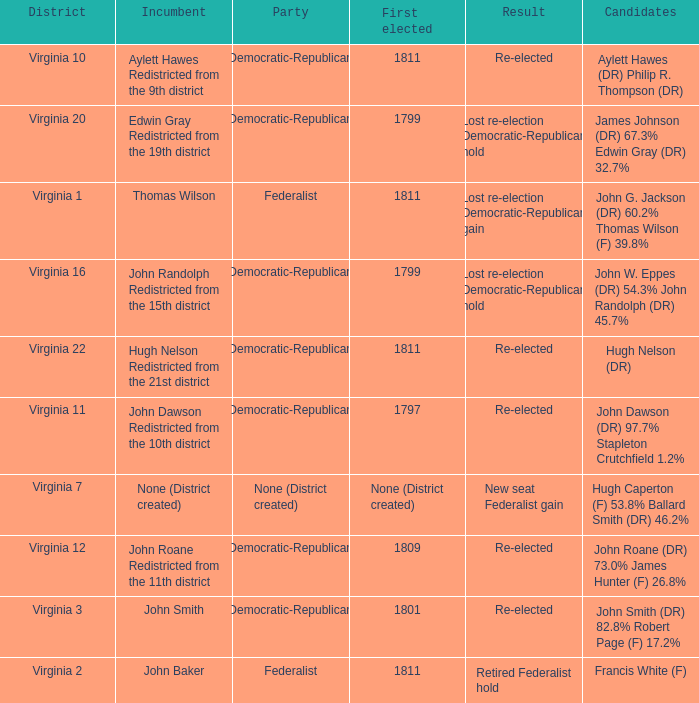Name the distrct for thomas wilson Virginia 1. 